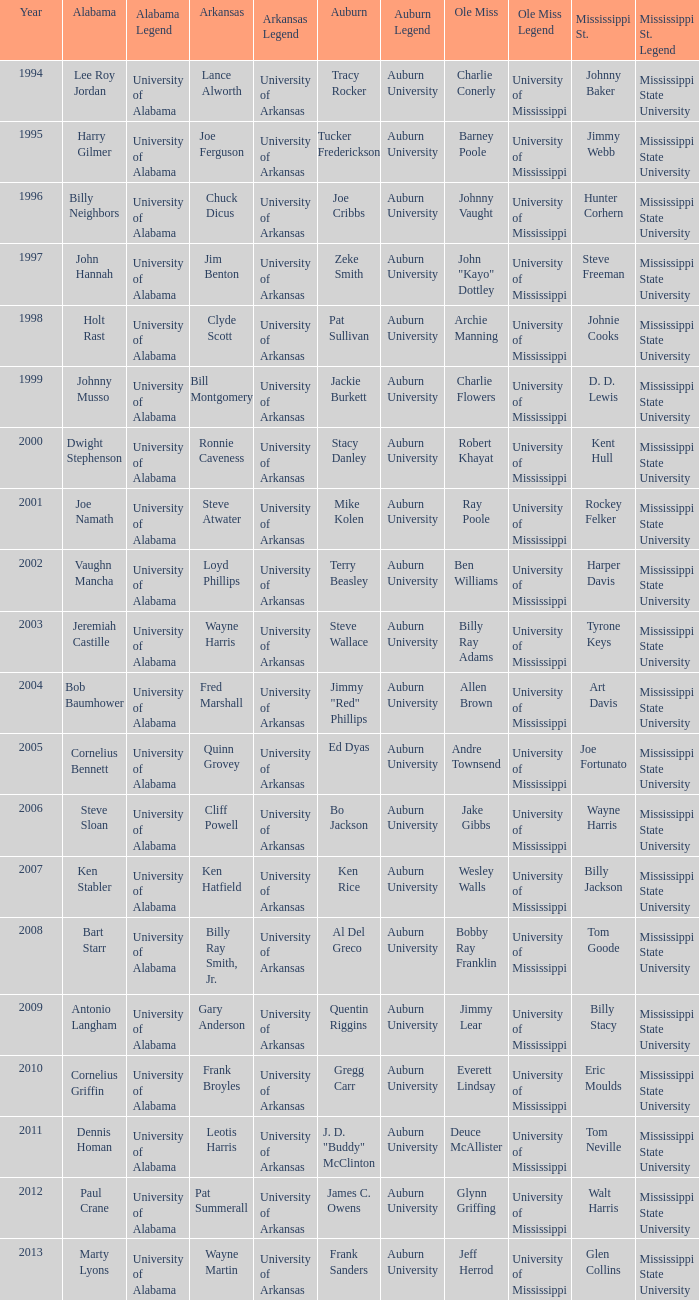Who was the Alabama player associated with Walt Harris? Paul Crane. I'm looking to parse the entire table for insights. Could you assist me with that? {'header': ['Year', 'Alabama', 'Alabama Legend', 'Arkansas', 'Arkansas Legend', 'Auburn', 'Auburn Legend', 'Ole Miss', 'Ole Miss Legend', 'Mississippi St.', 'Mississippi St. Legend'], 'rows': [['1994', 'Lee Roy Jordan', 'University of Alabama', 'Lance Alworth', 'University of Arkansas', 'Tracy Rocker', 'Auburn University', 'Charlie Conerly', 'University of Mississippi', 'Johnny Baker', 'Mississippi State University'], ['1995', 'Harry Gilmer', 'University of Alabama', 'Joe Ferguson', 'University of Arkansas', 'Tucker Frederickson', 'Auburn University', 'Barney Poole', 'University of Mississippi', 'Jimmy Webb', 'Mississippi State University'], ['1996', 'Billy Neighbors', 'University of Alabama', 'Chuck Dicus', 'University of Arkansas', 'Joe Cribbs', 'Auburn University', 'Johnny Vaught', 'University of Mississippi', 'Hunter Corhern', 'Mississippi State University'], ['1997', 'John Hannah', 'University of Alabama', 'Jim Benton', 'University of Arkansas', 'Zeke Smith', 'Auburn University', 'John "Kayo" Dottley', 'University of Mississippi', 'Steve Freeman', 'Mississippi State University'], ['1998', 'Holt Rast', 'University of Alabama', 'Clyde Scott', 'University of Arkansas', 'Pat Sullivan', 'Auburn University', 'Archie Manning', 'University of Mississippi', 'Johnie Cooks', 'Mississippi State University'], ['1999', 'Johnny Musso', 'University of Alabama', 'Bill Montgomery', 'University of Arkansas', 'Jackie Burkett', 'Auburn University', 'Charlie Flowers', 'University of Mississippi', 'D. D. Lewis', 'Mississippi State University'], ['2000', 'Dwight Stephenson', 'University of Alabama', 'Ronnie Caveness', 'University of Arkansas', 'Stacy Danley', 'Auburn University', 'Robert Khayat', 'University of Mississippi', 'Kent Hull', 'Mississippi State University'], ['2001', 'Joe Namath', 'University of Alabama', 'Steve Atwater', 'University of Arkansas', 'Mike Kolen', 'Auburn University', 'Ray Poole', 'University of Mississippi', 'Rockey Felker', 'Mississippi State University'], ['2002', 'Vaughn Mancha', 'University of Alabama', 'Loyd Phillips', 'University of Arkansas', 'Terry Beasley', 'Auburn University', 'Ben Williams', 'University of Mississippi', 'Harper Davis', 'Mississippi State University'], ['2003', 'Jeremiah Castille', 'University of Alabama', 'Wayne Harris', 'University of Arkansas', 'Steve Wallace', 'Auburn University', 'Billy Ray Adams', 'University of Mississippi', 'Tyrone Keys', 'Mississippi State University'], ['2004', 'Bob Baumhower', 'University of Alabama', 'Fred Marshall', 'University of Arkansas', 'Jimmy "Red" Phillips', 'Auburn University', 'Allen Brown', 'University of Mississippi', 'Art Davis', 'Mississippi State University'], ['2005', 'Cornelius Bennett', 'University of Alabama', 'Quinn Grovey', 'University of Arkansas', 'Ed Dyas', 'Auburn University', 'Andre Townsend', 'University of Mississippi', 'Joe Fortunato', 'Mississippi State University'], ['2006', 'Steve Sloan', 'University of Alabama', 'Cliff Powell', 'University of Arkansas', 'Bo Jackson', 'Auburn University', 'Jake Gibbs', 'University of Mississippi', 'Wayne Harris', 'Mississippi State University'], ['2007', 'Ken Stabler', 'University of Alabama', 'Ken Hatfield', 'University of Arkansas', 'Ken Rice', 'Auburn University', 'Wesley Walls', 'University of Mississippi', 'Billy Jackson', 'Mississippi State University'], ['2008', 'Bart Starr', 'University of Alabama', 'Billy Ray Smith, Jr.', 'University of Arkansas', 'Al Del Greco', 'Auburn University', 'Bobby Ray Franklin', 'University of Mississippi', 'Tom Goode', 'Mississippi State University'], ['2009', 'Antonio Langham', 'University of Alabama', 'Gary Anderson', 'University of Arkansas', 'Quentin Riggins', 'Auburn University', 'Jimmy Lear', 'University of Mississippi', 'Billy Stacy', 'Mississippi State University'], ['2010', 'Cornelius Griffin', 'University of Alabama', 'Frank Broyles', 'University of Arkansas', 'Gregg Carr', 'Auburn University', 'Everett Lindsay', 'University of Mississippi', 'Eric Moulds', 'Mississippi State University'], ['2011', 'Dennis Homan', 'University of Alabama', 'Leotis Harris', 'University of Arkansas', 'J. D. "Buddy" McClinton', 'Auburn University', 'Deuce McAllister', 'University of Mississippi', 'Tom Neville', 'Mississippi State University'], ['2012', 'Paul Crane', 'University of Alabama', 'Pat Summerall', 'University of Arkansas', 'James C. Owens', 'Auburn University', 'Glynn Griffing', 'University of Mississippi', 'Walt Harris', 'Mississippi State University'], ['2013', 'Marty Lyons', 'University of Alabama', 'Wayne Martin', 'University of Arkansas', 'Frank Sanders', 'Auburn University', 'Jeff Herrod', 'University of Mississippi', 'Glen Collins', 'Mississippi State University']]} 